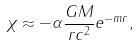<formula> <loc_0><loc_0><loc_500><loc_500>\chi \approx - \alpha \frac { G M } { r c ^ { 2 } } e ^ { - m r } ,</formula> 